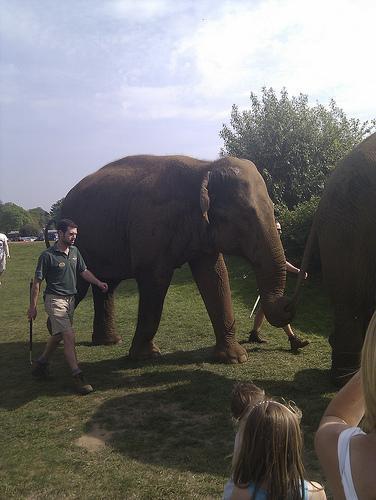How many elephants are visible?
Give a very brief answer. 2. 